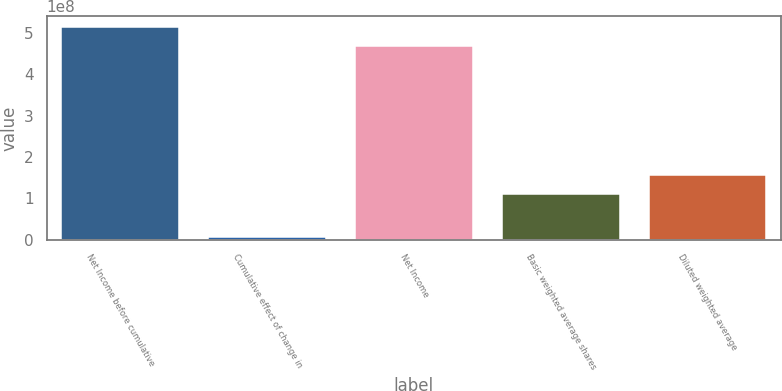Convert chart. <chart><loc_0><loc_0><loc_500><loc_500><bar_chart><fcel>Net Income before cumulative<fcel>Cumulative effect of change in<fcel>Net Income<fcel>Basic weighted average shares<fcel>Diluted weighted average<nl><fcel>5.1541e+08<fcel>7.163e+06<fcel>4.68555e+08<fcel>1.10106e+08<fcel>1.56962e+08<nl></chart> 